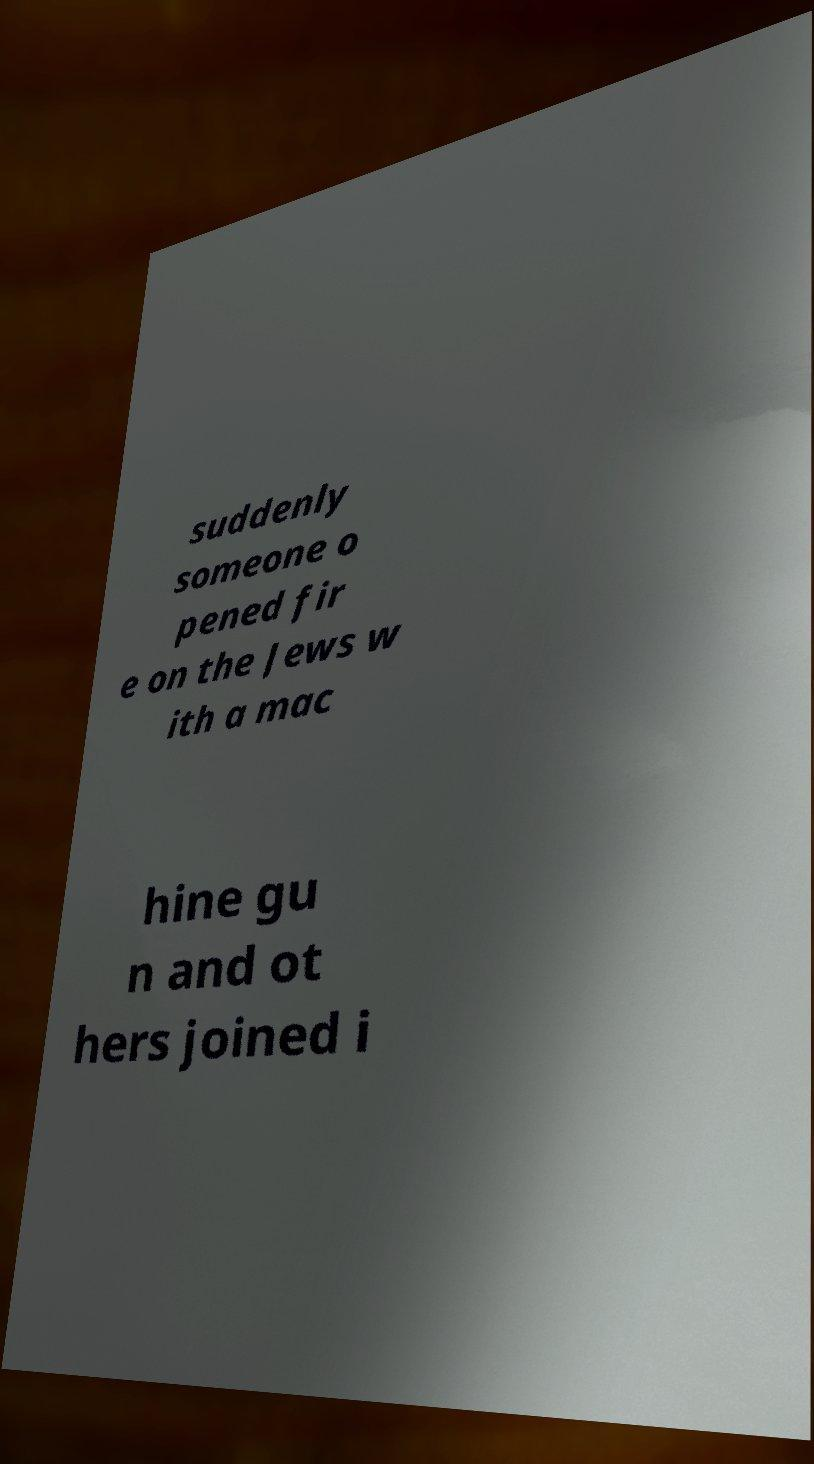Could you extract and type out the text from this image? suddenly someone o pened fir e on the Jews w ith a mac hine gu n and ot hers joined i 